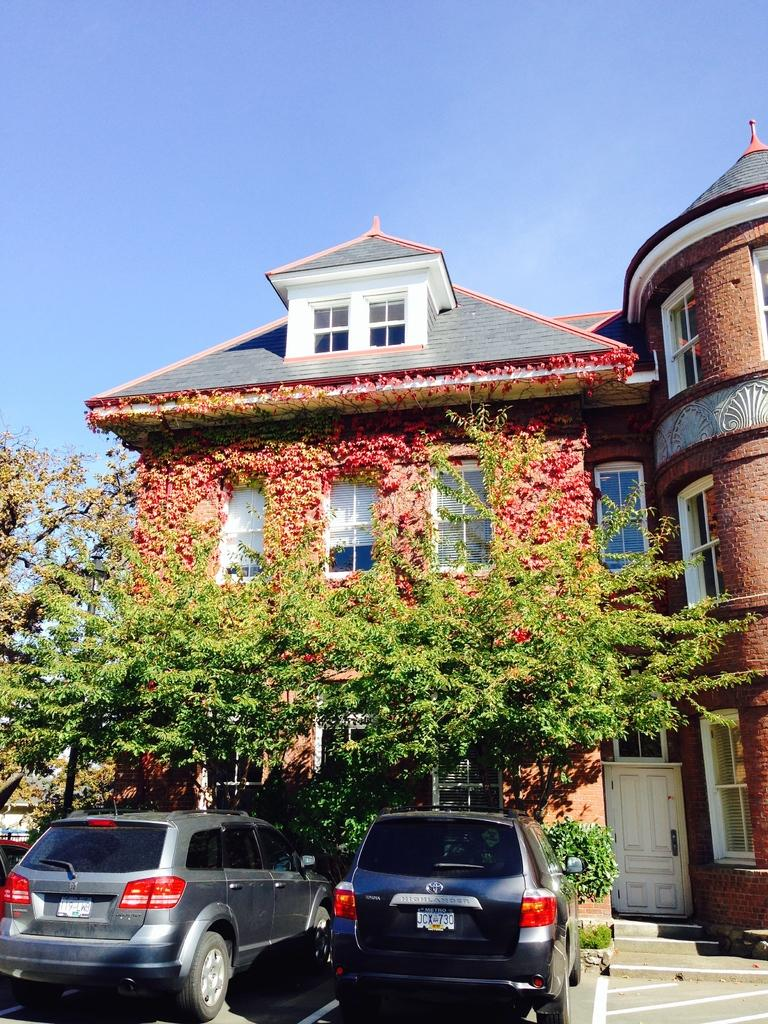What type of structures are present in the image? There are buildings in the image. What features can be seen on the buildings? The buildings have windows and doors. What type of vegetation is present in the image? There are trees and plants in the image. What is moving on the road in the image? There are vehicles on the road in the image. What can be seen in the background of the image? The sky is visible in the background of the image. How many horses can be seen running through the buildings in the image? There are no horses present in the image, and they are not running through the buildings. What type of grass is growing on the roofs of the buildings in the image? There is no grass visible on the roofs of the buildings in the image. 